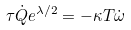<formula> <loc_0><loc_0><loc_500><loc_500>\tau \dot { Q } e ^ { \lambda / 2 } = - \kappa T \dot { \omega }</formula> 